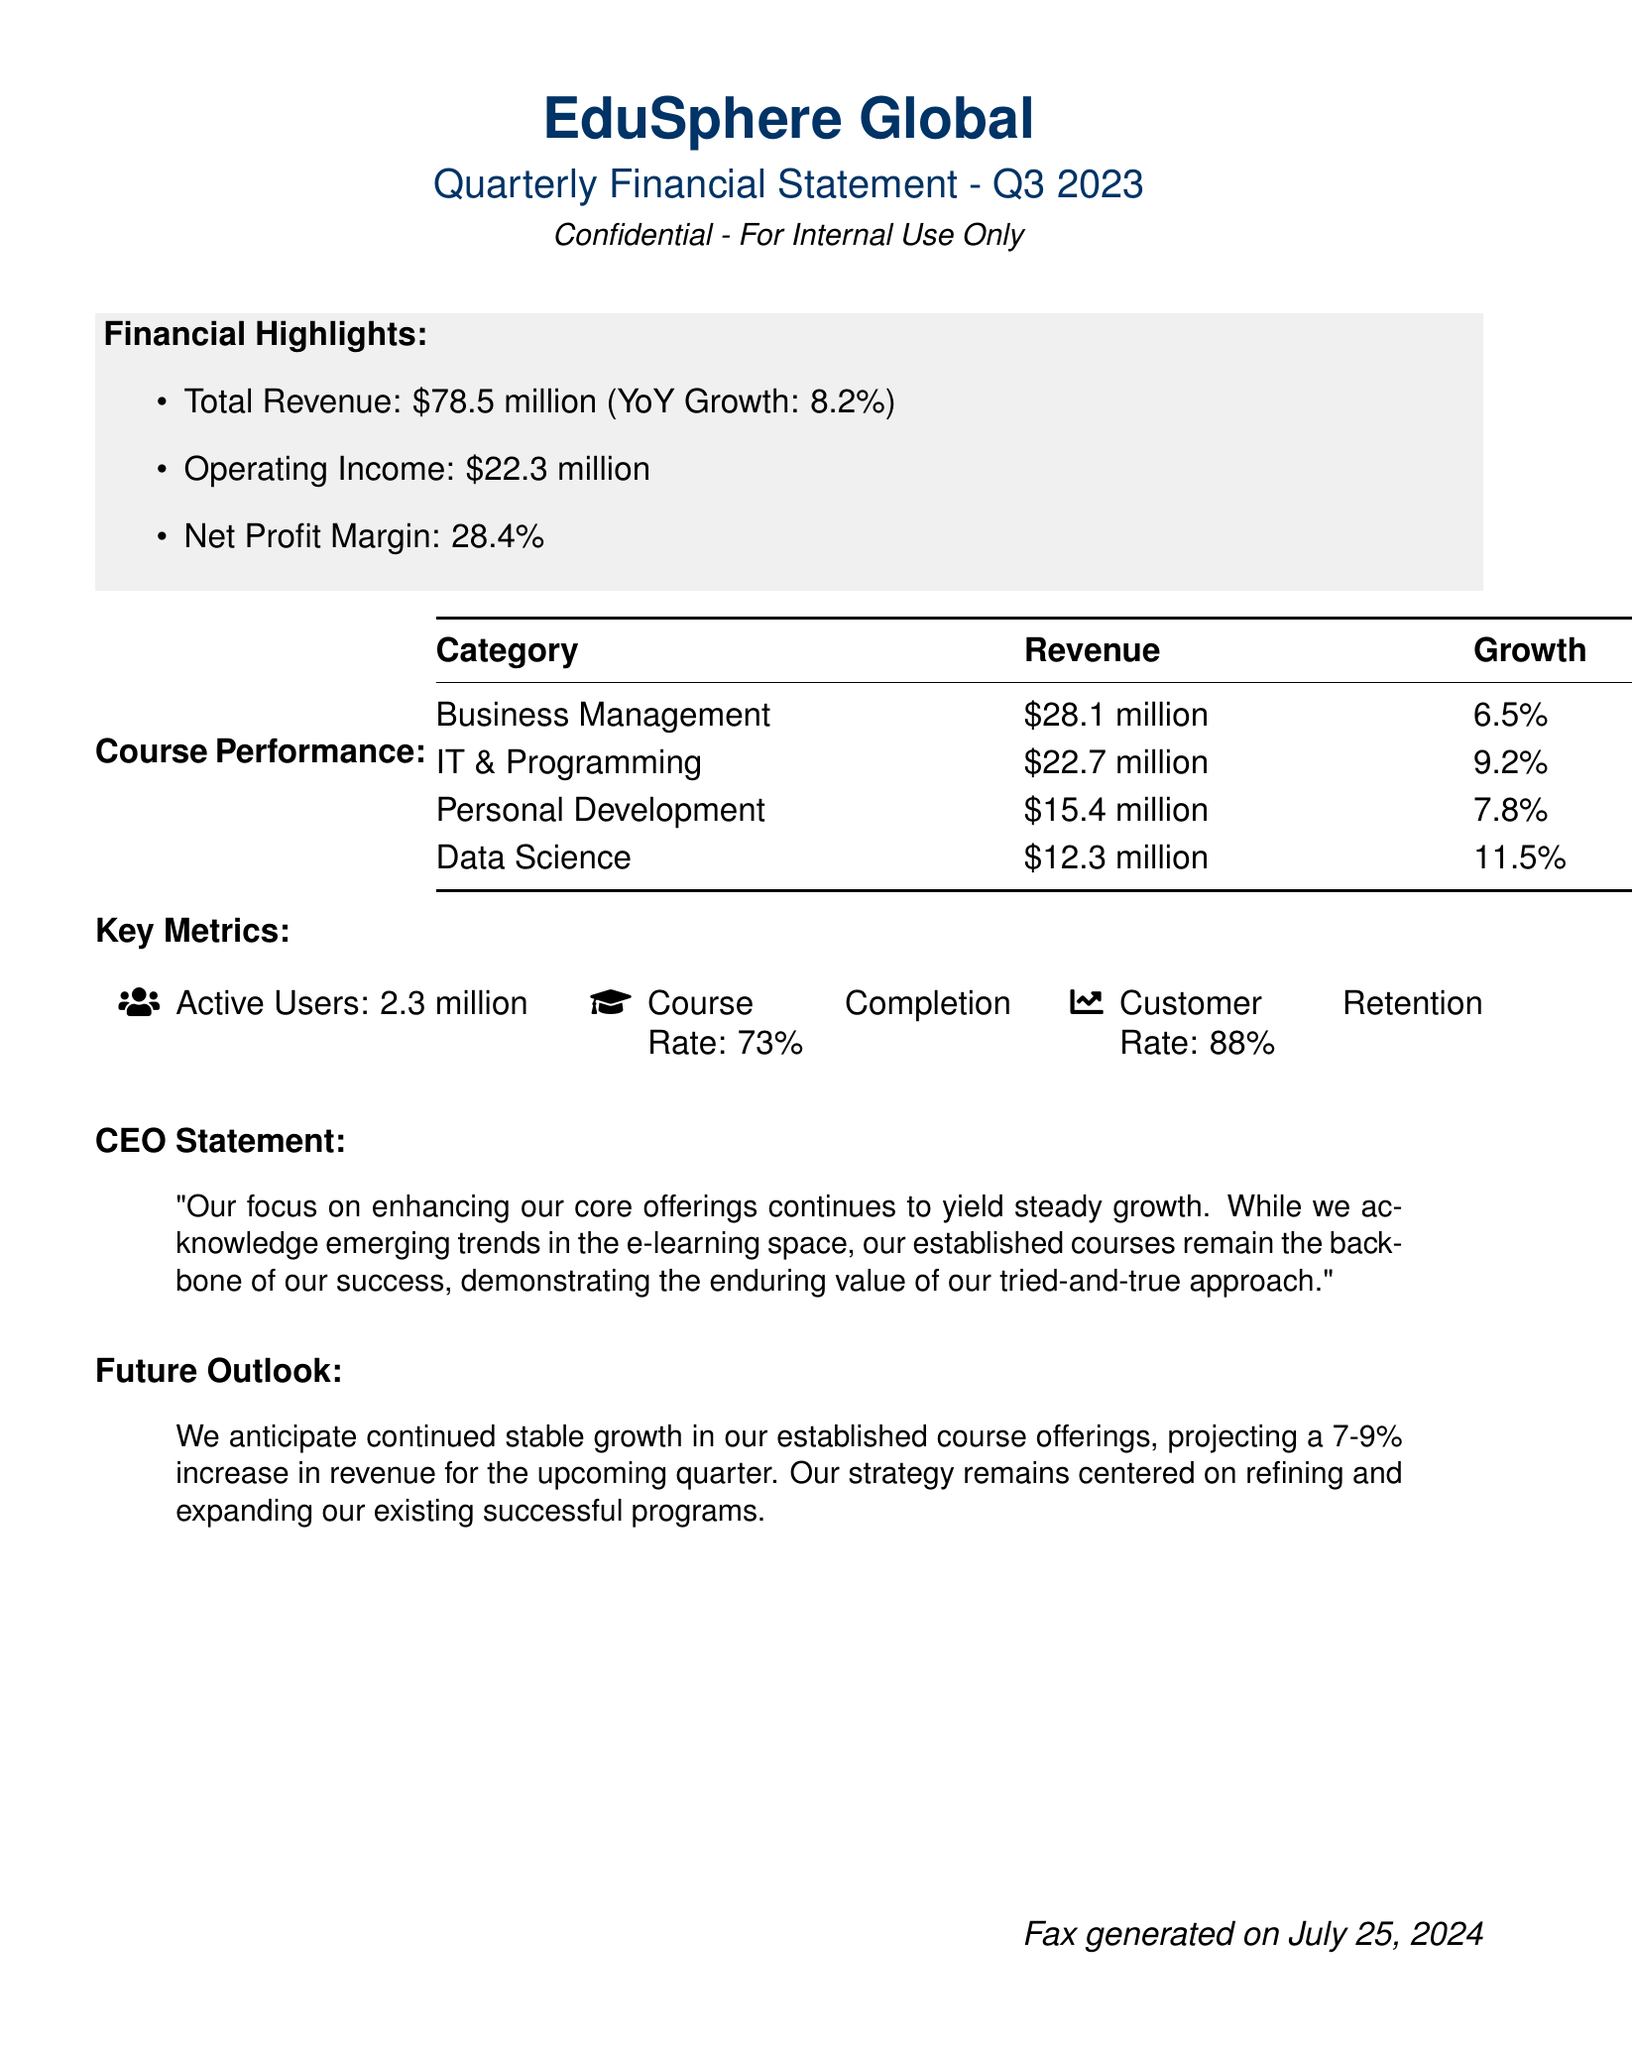What is the total revenue? The total revenue is explicitly stated in the document as $78.5 million.
Answer: $78.5 million What is the operating income? The operating income is provided as a separate line in the financial highlights.
Answer: $22.3 million What is the net profit margin? The net profit margin is listed under the financial highlights as a percentage.
Answer: 28.4% Which course category had the highest revenue? The revenue table shows Business Management as the top category with the highest revenue.
Answer: Business Management What is the customer retention rate? The customer retention rate is mentioned in the key metrics section.
Answer: 88% What is the projected revenue increase for the upcoming quarter? The future outlook section states the expected revenue increase for the next quarter.
Answer: 7-9% What growth percentage did Data Science experience? The growth percentage for Data Science is specifically listed in the course performance table.
Answer: 11.5% How many active users does EduSphere Global have? The document mentions the total number of active users in the key metrics section.
Answer: 2.3 million What does the CEO focus on for continued growth? The CEO statement emphasizes the focus on enhancing core offerings for sustained growth.
Answer: Enhancing core offerings 